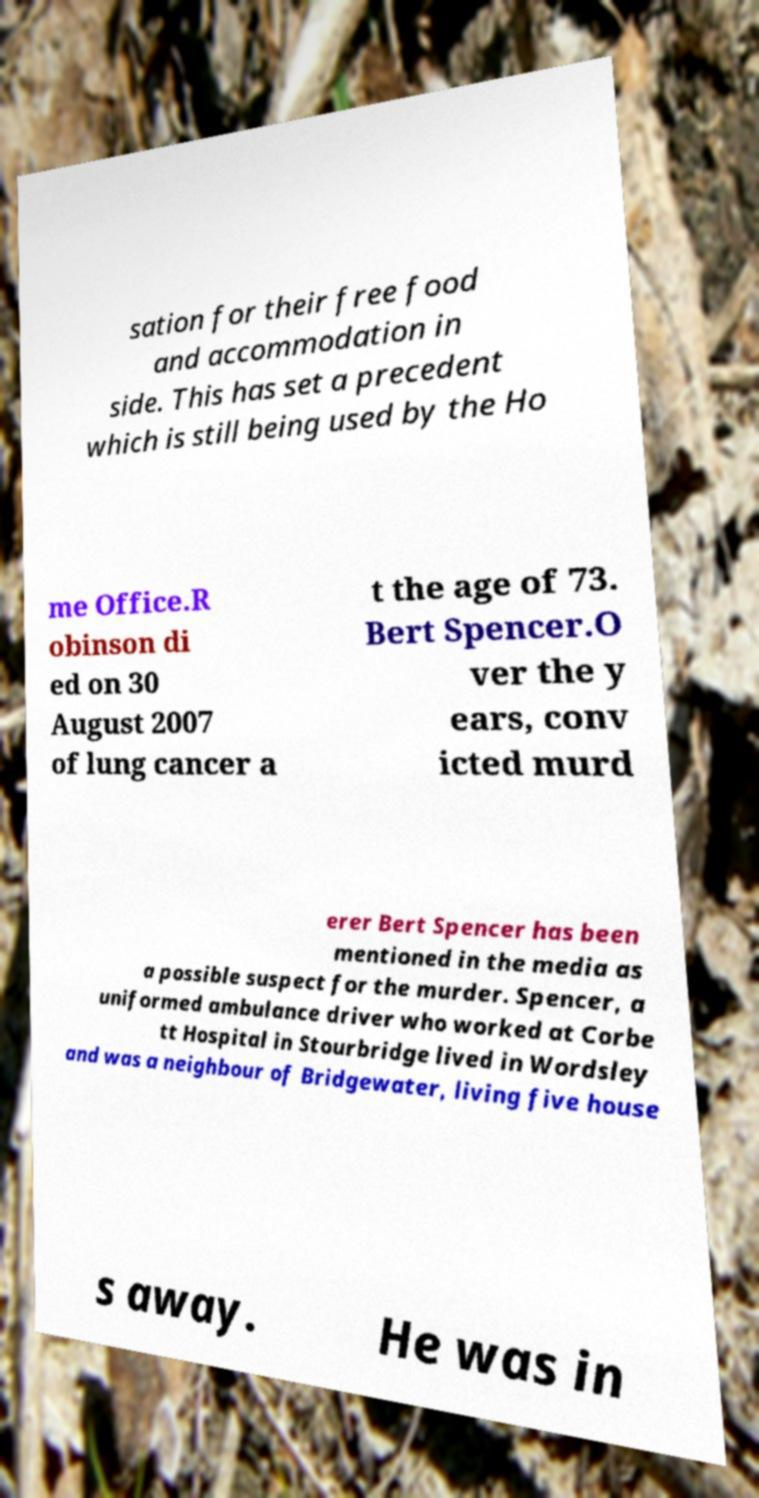Please read and relay the text visible in this image. What does it say? sation for their free food and accommodation in side. This has set a precedent which is still being used by the Ho me Office.R obinson di ed on 30 August 2007 of lung cancer a t the age of 73. Bert Spencer.O ver the y ears, conv icted murd erer Bert Spencer has been mentioned in the media as a possible suspect for the murder. Spencer, a uniformed ambulance driver who worked at Corbe tt Hospital in Stourbridge lived in Wordsley and was a neighbour of Bridgewater, living five house s away. He was in 